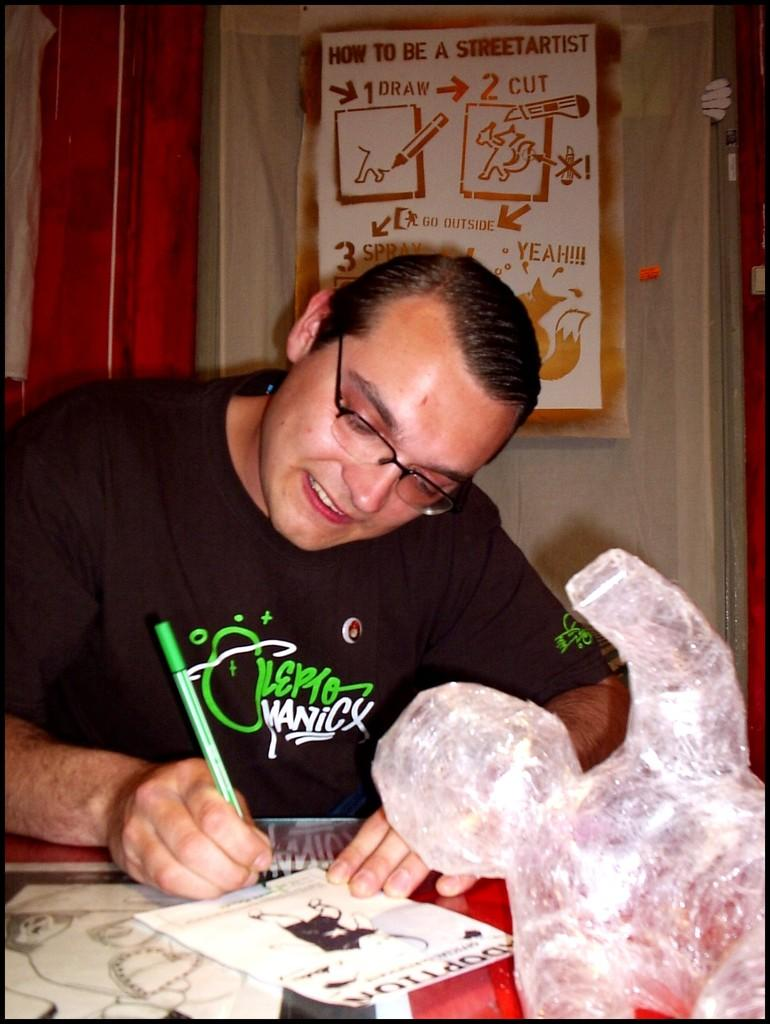What is the man in the image doing? The man is writing on a paper. What is the man wearing in the image? The man is wearing a black t-shirt. Can you describe anything on the wall in the image? There is a paper sticker on the wall in the image. What type of frogs can be seen in the image? There are no frogs present in the image. What is the name of the army unit the man belongs to in the image? There is no army unit or name mentioned in the image. 